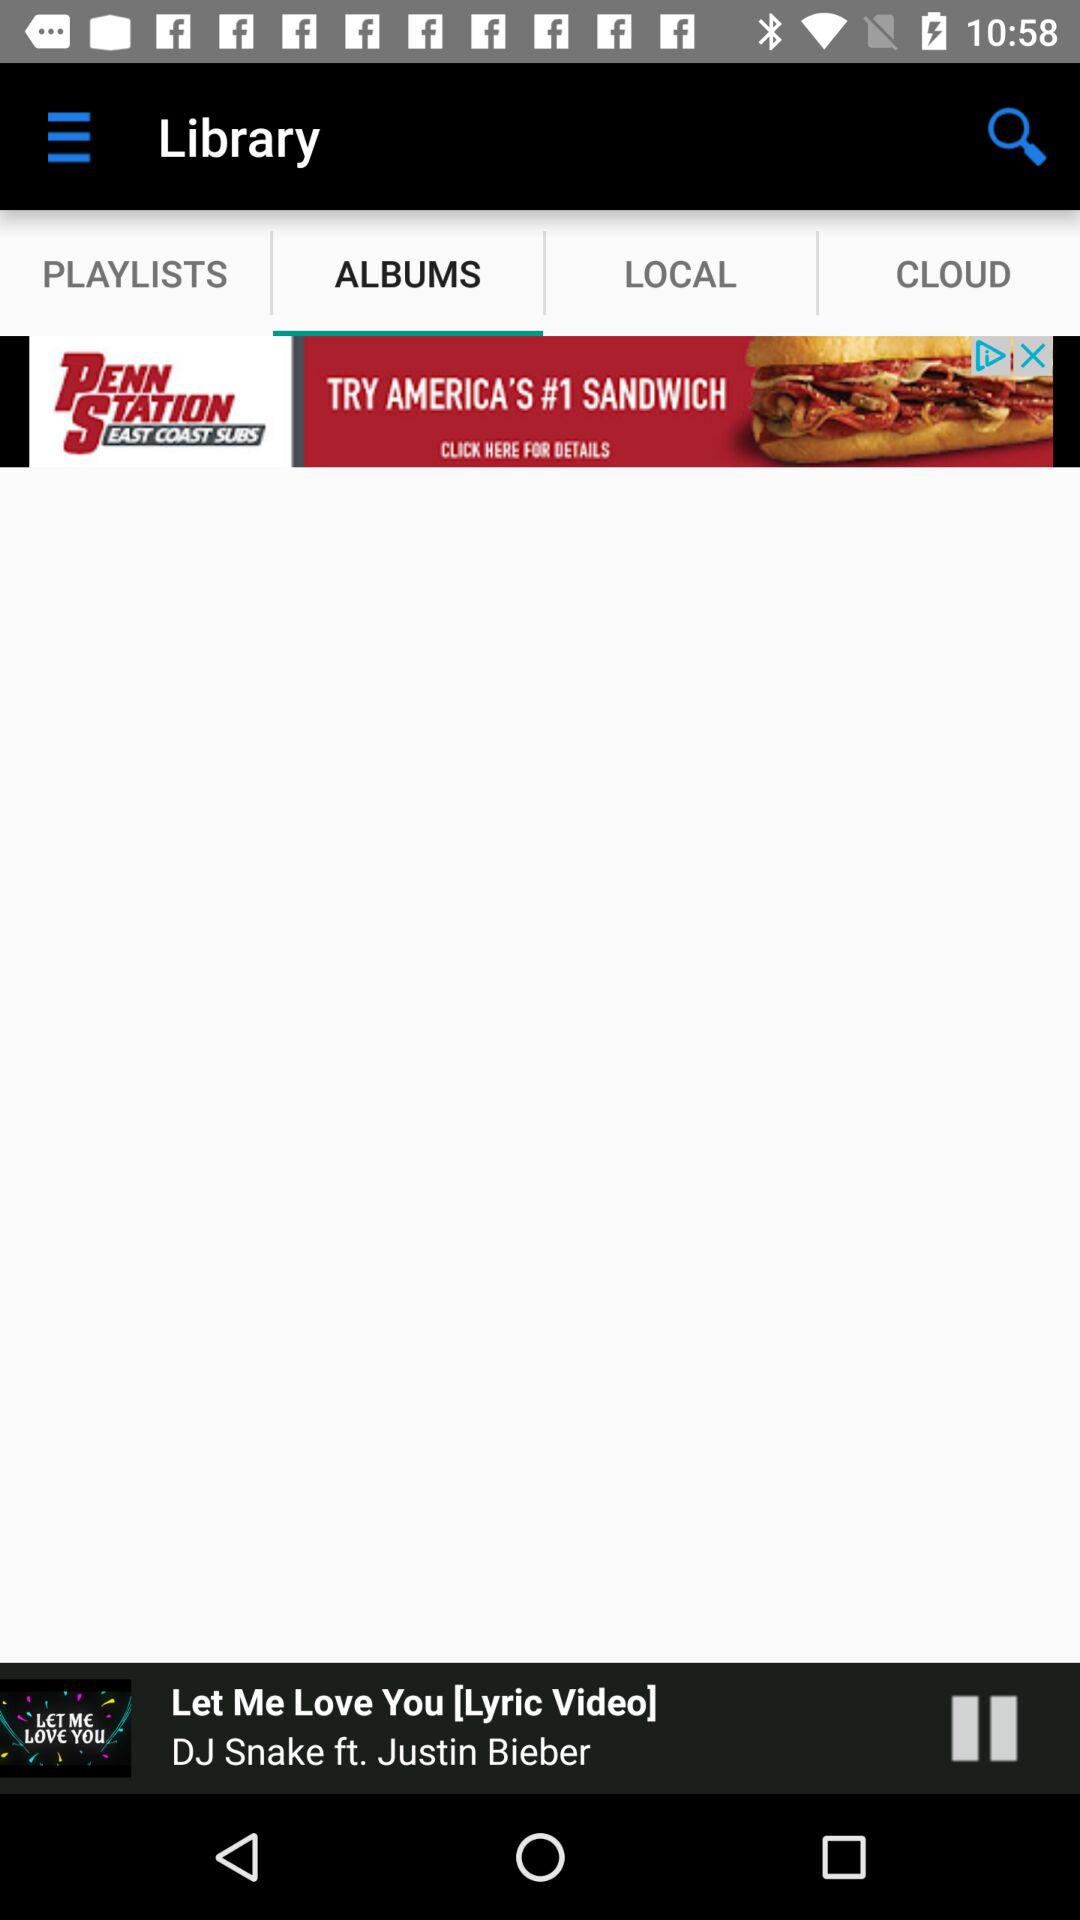What is the name of the current playing song? The name of the current playing song is "Let Me Love You [Lyric Video]". 